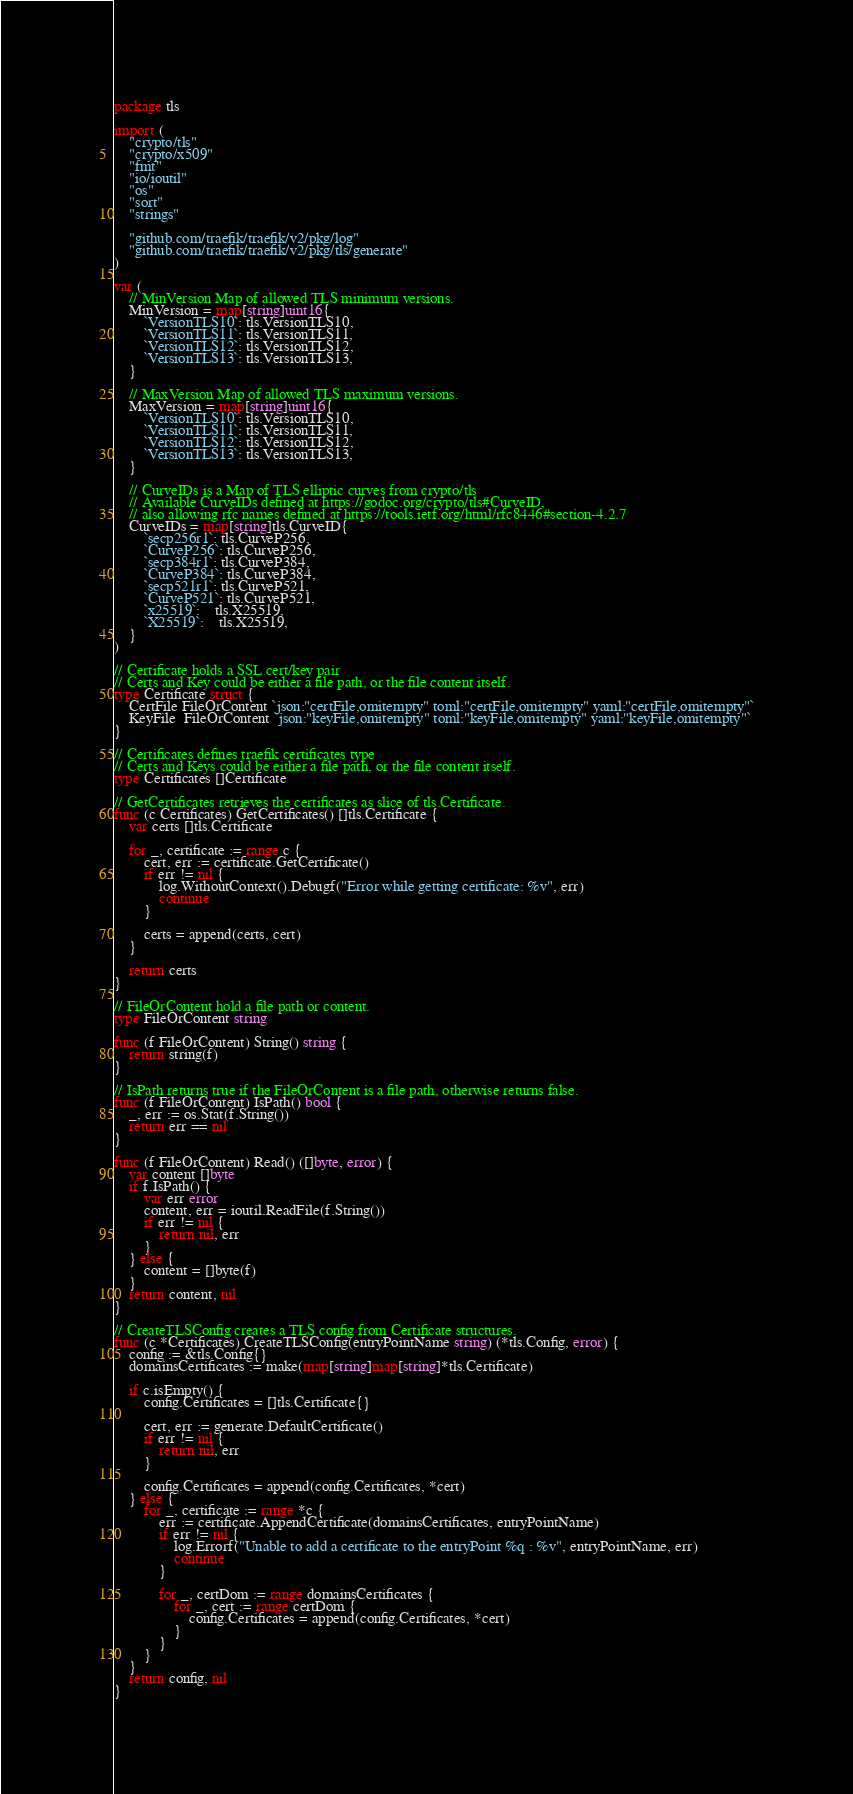<code> <loc_0><loc_0><loc_500><loc_500><_Go_>package tls

import (
	"crypto/tls"
	"crypto/x509"
	"fmt"
	"io/ioutil"
	"os"
	"sort"
	"strings"

	"github.com/traefik/traefik/v2/pkg/log"
	"github.com/traefik/traefik/v2/pkg/tls/generate"
)

var (
	// MinVersion Map of allowed TLS minimum versions.
	MinVersion = map[string]uint16{
		`VersionTLS10`: tls.VersionTLS10,
		`VersionTLS11`: tls.VersionTLS11,
		`VersionTLS12`: tls.VersionTLS12,
		`VersionTLS13`: tls.VersionTLS13,
	}

	// MaxVersion Map of allowed TLS maximum versions.
	MaxVersion = map[string]uint16{
		`VersionTLS10`: tls.VersionTLS10,
		`VersionTLS11`: tls.VersionTLS11,
		`VersionTLS12`: tls.VersionTLS12,
		`VersionTLS13`: tls.VersionTLS13,
	}

	// CurveIDs is a Map of TLS elliptic curves from crypto/tls
	// Available CurveIDs defined at https://godoc.org/crypto/tls#CurveID,
	// also allowing rfc names defined at https://tools.ietf.org/html/rfc8446#section-4.2.7
	CurveIDs = map[string]tls.CurveID{
		`secp256r1`: tls.CurveP256,
		`CurveP256`: tls.CurveP256,
		`secp384r1`: tls.CurveP384,
		`CurveP384`: tls.CurveP384,
		`secp521r1`: tls.CurveP521,
		`CurveP521`: tls.CurveP521,
		`x25519`:    tls.X25519,
		`X25519`:    tls.X25519,
	}
)

// Certificate holds a SSL cert/key pair
// Certs and Key could be either a file path, or the file content itself.
type Certificate struct {
	CertFile FileOrContent `json:"certFile,omitempty" toml:"certFile,omitempty" yaml:"certFile,omitempty"`
	KeyFile  FileOrContent `json:"keyFile,omitempty" toml:"keyFile,omitempty" yaml:"keyFile,omitempty"`
}

// Certificates defines traefik certificates type
// Certs and Keys could be either a file path, or the file content itself.
type Certificates []Certificate

// GetCertificates retrieves the certificates as slice of tls.Certificate.
func (c Certificates) GetCertificates() []tls.Certificate {
	var certs []tls.Certificate

	for _, certificate := range c {
		cert, err := certificate.GetCertificate()
		if err != nil {
			log.WithoutContext().Debugf("Error while getting certificate: %v", err)
			continue
		}

		certs = append(certs, cert)
	}

	return certs
}

// FileOrContent hold a file path or content.
type FileOrContent string

func (f FileOrContent) String() string {
	return string(f)
}

// IsPath returns true if the FileOrContent is a file path, otherwise returns false.
func (f FileOrContent) IsPath() bool {
	_, err := os.Stat(f.String())
	return err == nil
}

func (f FileOrContent) Read() ([]byte, error) {
	var content []byte
	if f.IsPath() {
		var err error
		content, err = ioutil.ReadFile(f.String())
		if err != nil {
			return nil, err
		}
	} else {
		content = []byte(f)
	}
	return content, nil
}

// CreateTLSConfig creates a TLS config from Certificate structures.
func (c *Certificates) CreateTLSConfig(entryPointName string) (*tls.Config, error) {
	config := &tls.Config{}
	domainsCertificates := make(map[string]map[string]*tls.Certificate)

	if c.isEmpty() {
		config.Certificates = []tls.Certificate{}

		cert, err := generate.DefaultCertificate()
		if err != nil {
			return nil, err
		}

		config.Certificates = append(config.Certificates, *cert)
	} else {
		for _, certificate := range *c {
			err := certificate.AppendCertificate(domainsCertificates, entryPointName)
			if err != nil {
				log.Errorf("Unable to add a certificate to the entryPoint %q : %v", entryPointName, err)
				continue
			}

			for _, certDom := range domainsCertificates {
				for _, cert := range certDom {
					config.Certificates = append(config.Certificates, *cert)
				}
			}
		}
	}
	return config, nil
}
</code> 